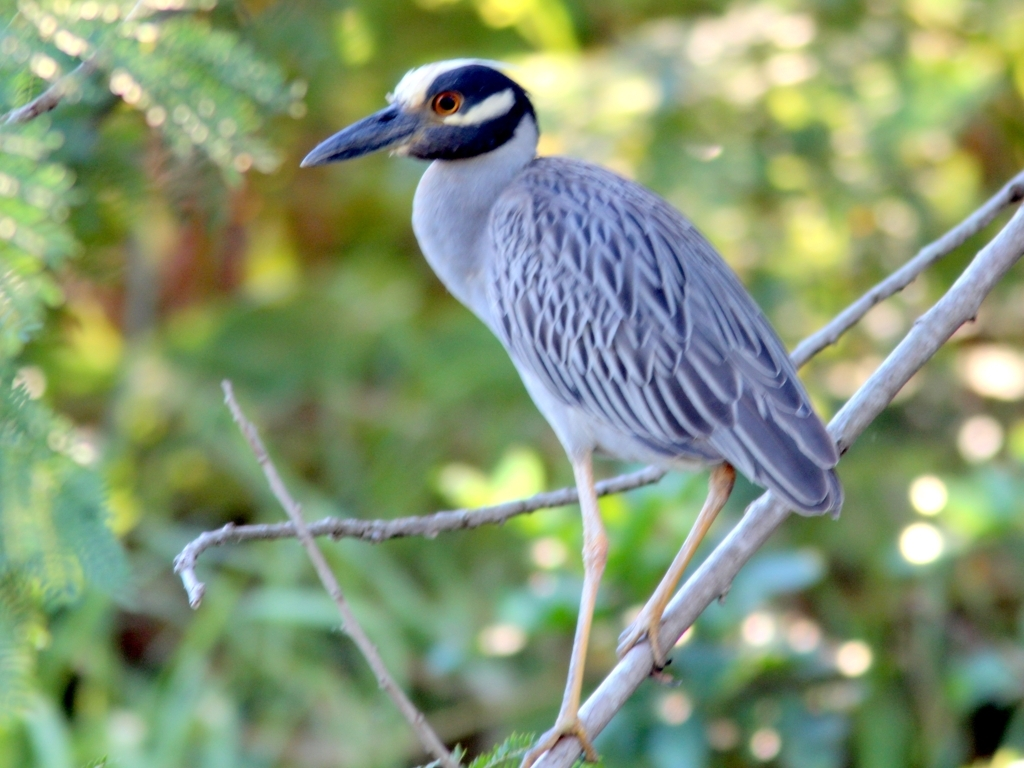Can you tell me about the clarity of the photo? What aspects make it good or bad quality? Overall, the photo is quite clear. The clarity is evident through the sharp details in the bird's feathers and the distinct color contrasts. However, the background appears to be slightly blurred, which actually helps in making the heron the main focus of the image. Does the blurriness of the background affect the quality of the image? The blurred background does not necessarily detract from the image quality; it's a common photographic technique known as 'bokeh', used to isolate the subject and provide a pleasing aesthetic by blurring the background. 